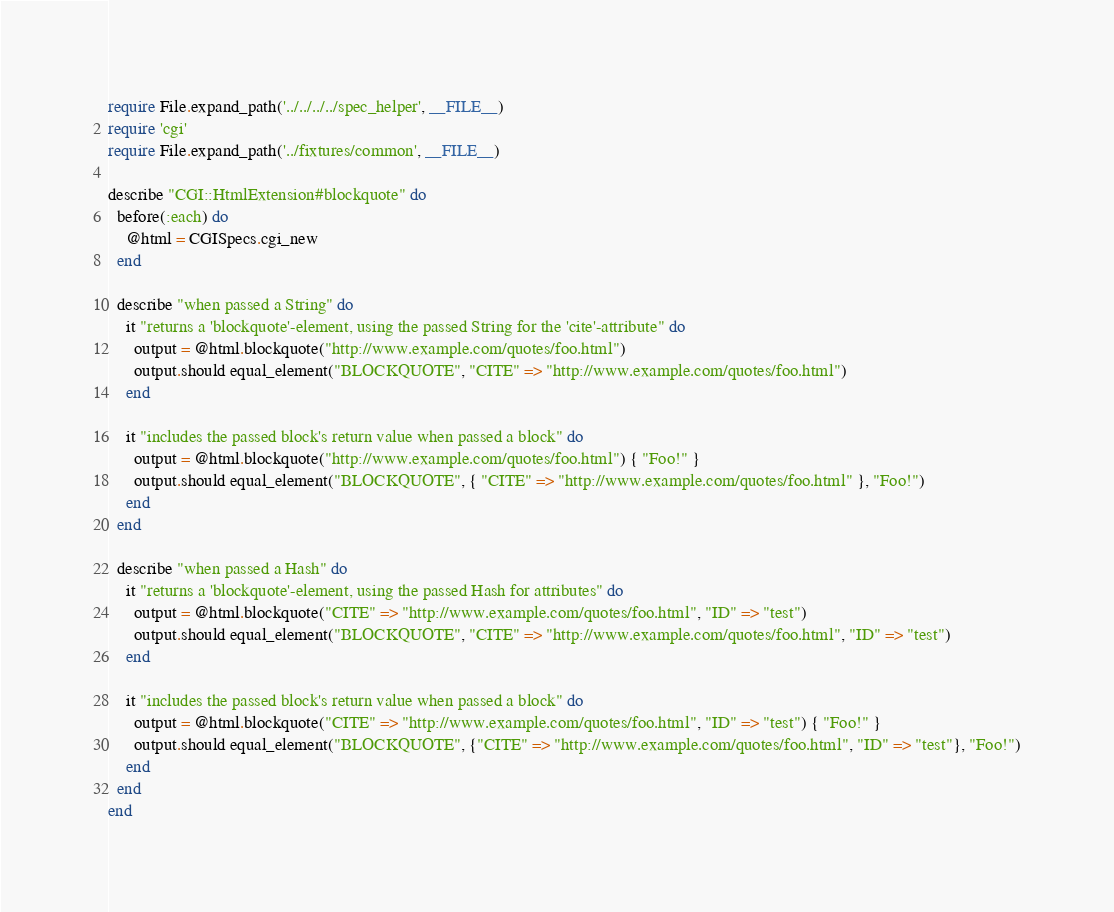Convert code to text. <code><loc_0><loc_0><loc_500><loc_500><_Ruby_>require File.expand_path('../../../../spec_helper', __FILE__)
require 'cgi'
require File.expand_path('../fixtures/common', __FILE__)

describe "CGI::HtmlExtension#blockquote" do
  before(:each) do
    @html = CGISpecs.cgi_new
  end
  
  describe "when passed a String" do
    it "returns a 'blockquote'-element, using the passed String for the 'cite'-attribute" do
      output = @html.blockquote("http://www.example.com/quotes/foo.html")
      output.should equal_element("BLOCKQUOTE", "CITE" => "http://www.example.com/quotes/foo.html")
    end

    it "includes the passed block's return value when passed a block" do
      output = @html.blockquote("http://www.example.com/quotes/foo.html") { "Foo!" }
      output.should equal_element("BLOCKQUOTE", { "CITE" => "http://www.example.com/quotes/foo.html" }, "Foo!")
    end
  end
  
  describe "when passed a Hash" do
    it "returns a 'blockquote'-element, using the passed Hash for attributes" do
      output = @html.blockquote("CITE" => "http://www.example.com/quotes/foo.html", "ID" => "test")
      output.should equal_element("BLOCKQUOTE", "CITE" => "http://www.example.com/quotes/foo.html", "ID" => "test")
    end

    it "includes the passed block's return value when passed a block" do
      output = @html.blockquote("CITE" => "http://www.example.com/quotes/foo.html", "ID" => "test") { "Foo!" }
      output.should equal_element("BLOCKQUOTE", {"CITE" => "http://www.example.com/quotes/foo.html", "ID" => "test"}, "Foo!")
    end
  end
end</code> 